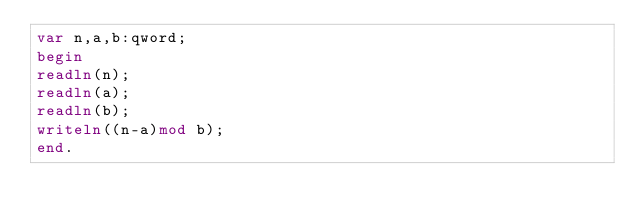Convert code to text. <code><loc_0><loc_0><loc_500><loc_500><_Pascal_>var n,a,b:qword;
begin
readln(n);
readln(a);
readln(b);
writeln((n-a)mod b);
end.</code> 